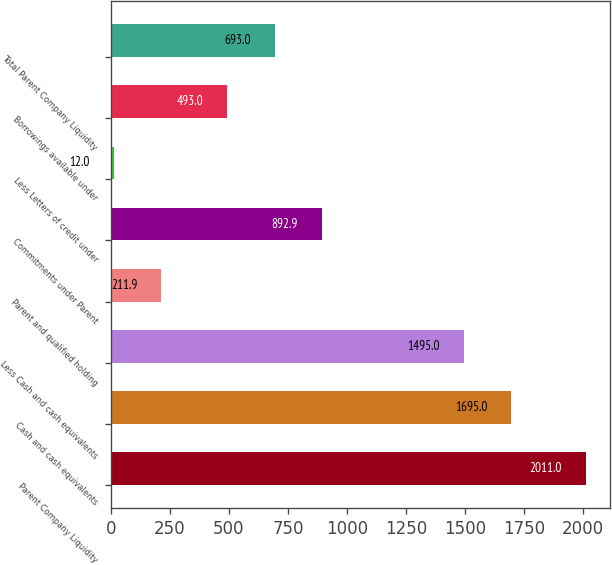Convert chart to OTSL. <chart><loc_0><loc_0><loc_500><loc_500><bar_chart><fcel>Parent Company Liquidity<fcel>Cash and cash equivalents<fcel>Less Cash and cash equivalents<fcel>Parent and qualified holding<fcel>Commitments under Parent<fcel>Less Letters of credit under<fcel>Borrowings available under<fcel>Total Parent Company Liquidity<nl><fcel>2011<fcel>1695<fcel>1495<fcel>211.9<fcel>892.9<fcel>12<fcel>493<fcel>693<nl></chart> 